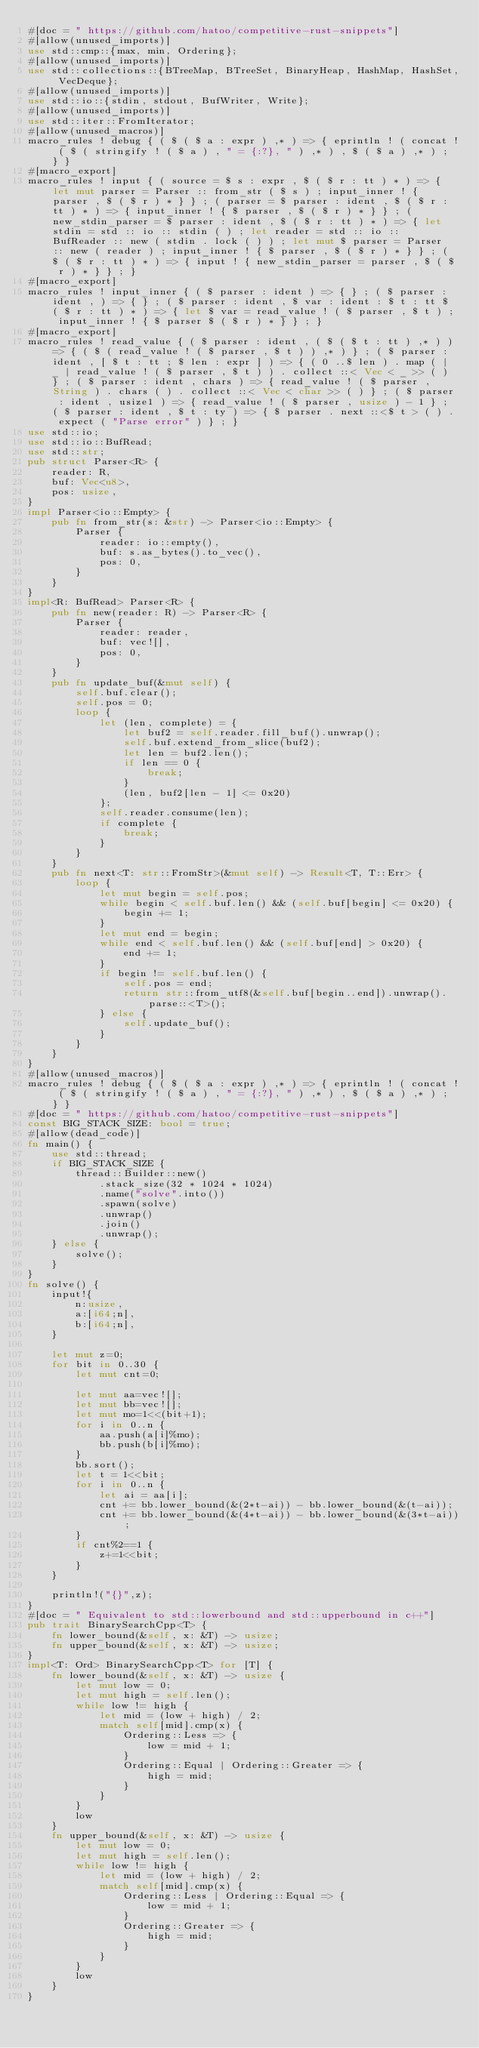<code> <loc_0><loc_0><loc_500><loc_500><_Rust_>#[doc = " https://github.com/hatoo/competitive-rust-snippets"]
#[allow(unused_imports)]
use std::cmp::{max, min, Ordering};
#[allow(unused_imports)]
use std::collections::{BTreeMap, BTreeSet, BinaryHeap, HashMap, HashSet, VecDeque};
#[allow(unused_imports)]
use std::io::{stdin, stdout, BufWriter, Write};
#[allow(unused_imports)]
use std::iter::FromIterator;
#[allow(unused_macros)]
macro_rules ! debug { ( $ ( $ a : expr ) ,* ) => { eprintln ! ( concat ! ( $ ( stringify ! ( $ a ) , " = {:?}, " ) ,* ) , $ ( $ a ) ,* ) ; } }
#[macro_export]
macro_rules ! input { ( source = $ s : expr , $ ( $ r : tt ) * ) => { let mut parser = Parser :: from_str ( $ s ) ; input_inner ! { parser , $ ( $ r ) * } } ; ( parser = $ parser : ident , $ ( $ r : tt ) * ) => { input_inner ! { $ parser , $ ( $ r ) * } } ; ( new_stdin_parser = $ parser : ident , $ ( $ r : tt ) * ) => { let stdin = std :: io :: stdin ( ) ; let reader = std :: io :: BufReader :: new ( stdin . lock ( ) ) ; let mut $ parser = Parser :: new ( reader ) ; input_inner ! { $ parser , $ ( $ r ) * } } ; ( $ ( $ r : tt ) * ) => { input ! { new_stdin_parser = parser , $ ( $ r ) * } } ; }
#[macro_export]
macro_rules ! input_inner { ( $ parser : ident ) => { } ; ( $ parser : ident , ) => { } ; ( $ parser : ident , $ var : ident : $ t : tt $ ( $ r : tt ) * ) => { let $ var = read_value ! ( $ parser , $ t ) ; input_inner ! { $ parser $ ( $ r ) * } } ; }
#[macro_export]
macro_rules ! read_value { ( $ parser : ident , ( $ ( $ t : tt ) ,* ) ) => { ( $ ( read_value ! ( $ parser , $ t ) ) ,* ) } ; ( $ parser : ident , [ $ t : tt ; $ len : expr ] ) => { ( 0 ..$ len ) . map ( | _ | read_value ! ( $ parser , $ t ) ) . collect ::< Vec < _ >> ( ) } ; ( $ parser : ident , chars ) => { read_value ! ( $ parser , String ) . chars ( ) . collect ::< Vec < char >> ( ) } ; ( $ parser : ident , usize1 ) => { read_value ! ( $ parser , usize ) - 1 } ; ( $ parser : ident , $ t : ty ) => { $ parser . next ::<$ t > ( ) . expect ( "Parse error" ) } ; }
use std::io;
use std::io::BufRead;
use std::str;
pub struct Parser<R> {
    reader: R,
    buf: Vec<u8>,
    pos: usize,
}
impl Parser<io::Empty> {
    pub fn from_str(s: &str) -> Parser<io::Empty> {
        Parser {
            reader: io::empty(),
            buf: s.as_bytes().to_vec(),
            pos: 0,
        }
    }
}
impl<R: BufRead> Parser<R> {
    pub fn new(reader: R) -> Parser<R> {
        Parser {
            reader: reader,
            buf: vec![],
            pos: 0,
        }
    }
    pub fn update_buf(&mut self) {
        self.buf.clear();
        self.pos = 0;
        loop {
            let (len, complete) = {
                let buf2 = self.reader.fill_buf().unwrap();
                self.buf.extend_from_slice(buf2);
                let len = buf2.len();
                if len == 0 {
                    break;
                }
                (len, buf2[len - 1] <= 0x20)
            };
            self.reader.consume(len);
            if complete {
                break;
            }
        }
    }
    pub fn next<T: str::FromStr>(&mut self) -> Result<T, T::Err> {
        loop {
            let mut begin = self.pos;
            while begin < self.buf.len() && (self.buf[begin] <= 0x20) {
                begin += 1;
            }
            let mut end = begin;
            while end < self.buf.len() && (self.buf[end] > 0x20) {
                end += 1;
            }
            if begin != self.buf.len() {
                self.pos = end;
                return str::from_utf8(&self.buf[begin..end]).unwrap().parse::<T>();
            } else {
                self.update_buf();
            }
        }
    }
}
#[allow(unused_macros)]
macro_rules ! debug { ( $ ( $ a : expr ) ,* ) => { eprintln ! ( concat ! ( $ ( stringify ! ( $ a ) , " = {:?}, " ) ,* ) , $ ( $ a ) ,* ) ; } }
#[doc = " https://github.com/hatoo/competitive-rust-snippets"]
const BIG_STACK_SIZE: bool = true;
#[allow(dead_code)]
fn main() {
    use std::thread;
    if BIG_STACK_SIZE {
        thread::Builder::new()
            .stack_size(32 * 1024 * 1024)
            .name("solve".into())
            .spawn(solve)
            .unwrap()
            .join()
            .unwrap();
    } else {
        solve();
    }
}
fn solve() {
    input!{
        n:usize,
        a:[i64;n],
        b:[i64;n],
    }

    let mut z=0;
    for bit in 0..30 {
        let mut cnt=0;

        let mut aa=vec![];
        let mut bb=vec![];
        let mut mo=1<<(bit+1);
        for i in 0..n {
            aa.push(a[i]%mo);
            bb.push(b[i]%mo);
        }
        bb.sort();
        let t = 1<<bit;
        for i in 0..n {
            let ai = aa[i];
            cnt += bb.lower_bound(&(2*t-ai)) - bb.lower_bound(&(t-ai));
            cnt += bb.lower_bound(&(4*t-ai)) - bb.lower_bound(&(3*t-ai));
        }
        if cnt%2==1 {
            z+=1<<bit;
        }
    }

    println!("{}",z);
}
#[doc = " Equivalent to std::lowerbound and std::upperbound in c++"]
pub trait BinarySearchCpp<T> {
    fn lower_bound(&self, x: &T) -> usize;
    fn upper_bound(&self, x: &T) -> usize;
}
impl<T: Ord> BinarySearchCpp<T> for [T] {
    fn lower_bound(&self, x: &T) -> usize {
        let mut low = 0;
        let mut high = self.len();
        while low != high {
            let mid = (low + high) / 2;
            match self[mid].cmp(x) {
                Ordering::Less => {
                    low = mid + 1;
                }
                Ordering::Equal | Ordering::Greater => {
                    high = mid;
                }
            }
        }
        low
    }
    fn upper_bound(&self, x: &T) -> usize {
        let mut low = 0;
        let mut high = self.len();
        while low != high {
            let mid = (low + high) / 2;
            match self[mid].cmp(x) {
                Ordering::Less | Ordering::Equal => {
                    low = mid + 1;
                }
                Ordering::Greater => {
                    high = mid;
                }
            }
        }
        low
    }
}</code> 